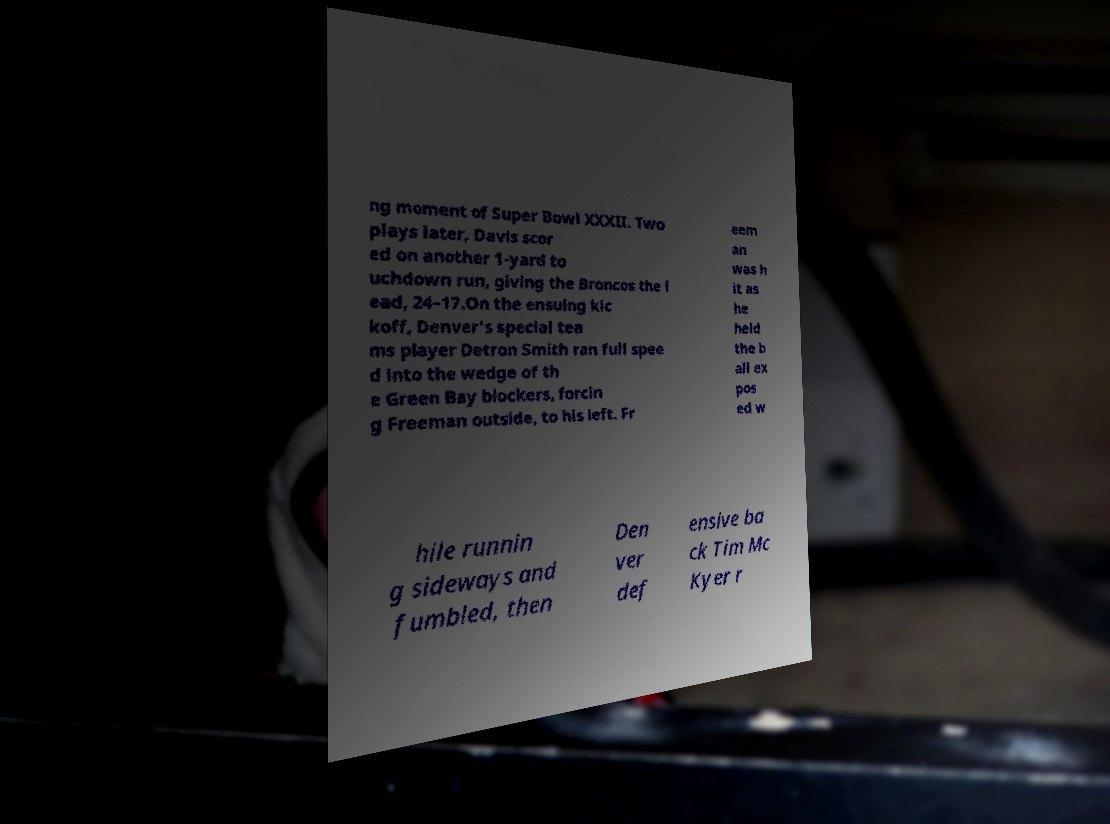I need the written content from this picture converted into text. Can you do that? ng moment of Super Bowl XXXII. Two plays later, Davis scor ed on another 1-yard to uchdown run, giving the Broncos the l ead, 24–17.On the ensuing kic koff, Denver's special tea ms player Detron Smith ran full spee d into the wedge of th e Green Bay blockers, forcin g Freeman outside, to his left. Fr eem an was h it as he held the b all ex pos ed w hile runnin g sideways and fumbled, then Den ver def ensive ba ck Tim Mc Kyer r 